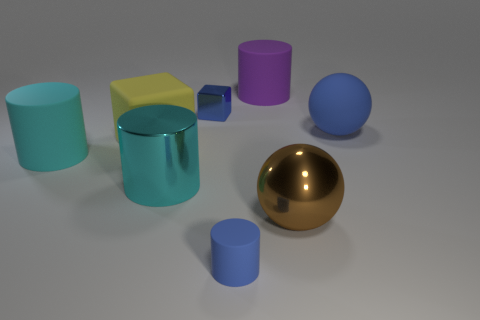What number of other objects are the same color as the matte ball?
Offer a very short reply. 2. Is the material of the brown object in front of the tiny block the same as the small blue thing that is in front of the cyan shiny object?
Offer a terse response. No. Is the purple object made of the same material as the tiny thing that is behind the blue rubber cylinder?
Your answer should be compact. No. What material is the large cylinder to the right of the blue matte cylinder?
Your response must be concise. Rubber. There is a yellow rubber thing; is it the same size as the block that is on the right side of the yellow object?
Your response must be concise. No. Are there any blue shiny cubes to the left of the blue matte object that is behind the metal sphere?
Keep it short and to the point. Yes. What is the shape of the big cyan object to the right of the big yellow object?
Provide a succinct answer. Cylinder. There is another cylinder that is the same color as the large metal cylinder; what is it made of?
Provide a short and direct response. Rubber. What is the color of the big metallic thing that is right of the large purple matte cylinder that is behind the blue metal object?
Give a very brief answer. Brown. Do the yellow object and the blue metallic object have the same size?
Give a very brief answer. No. 